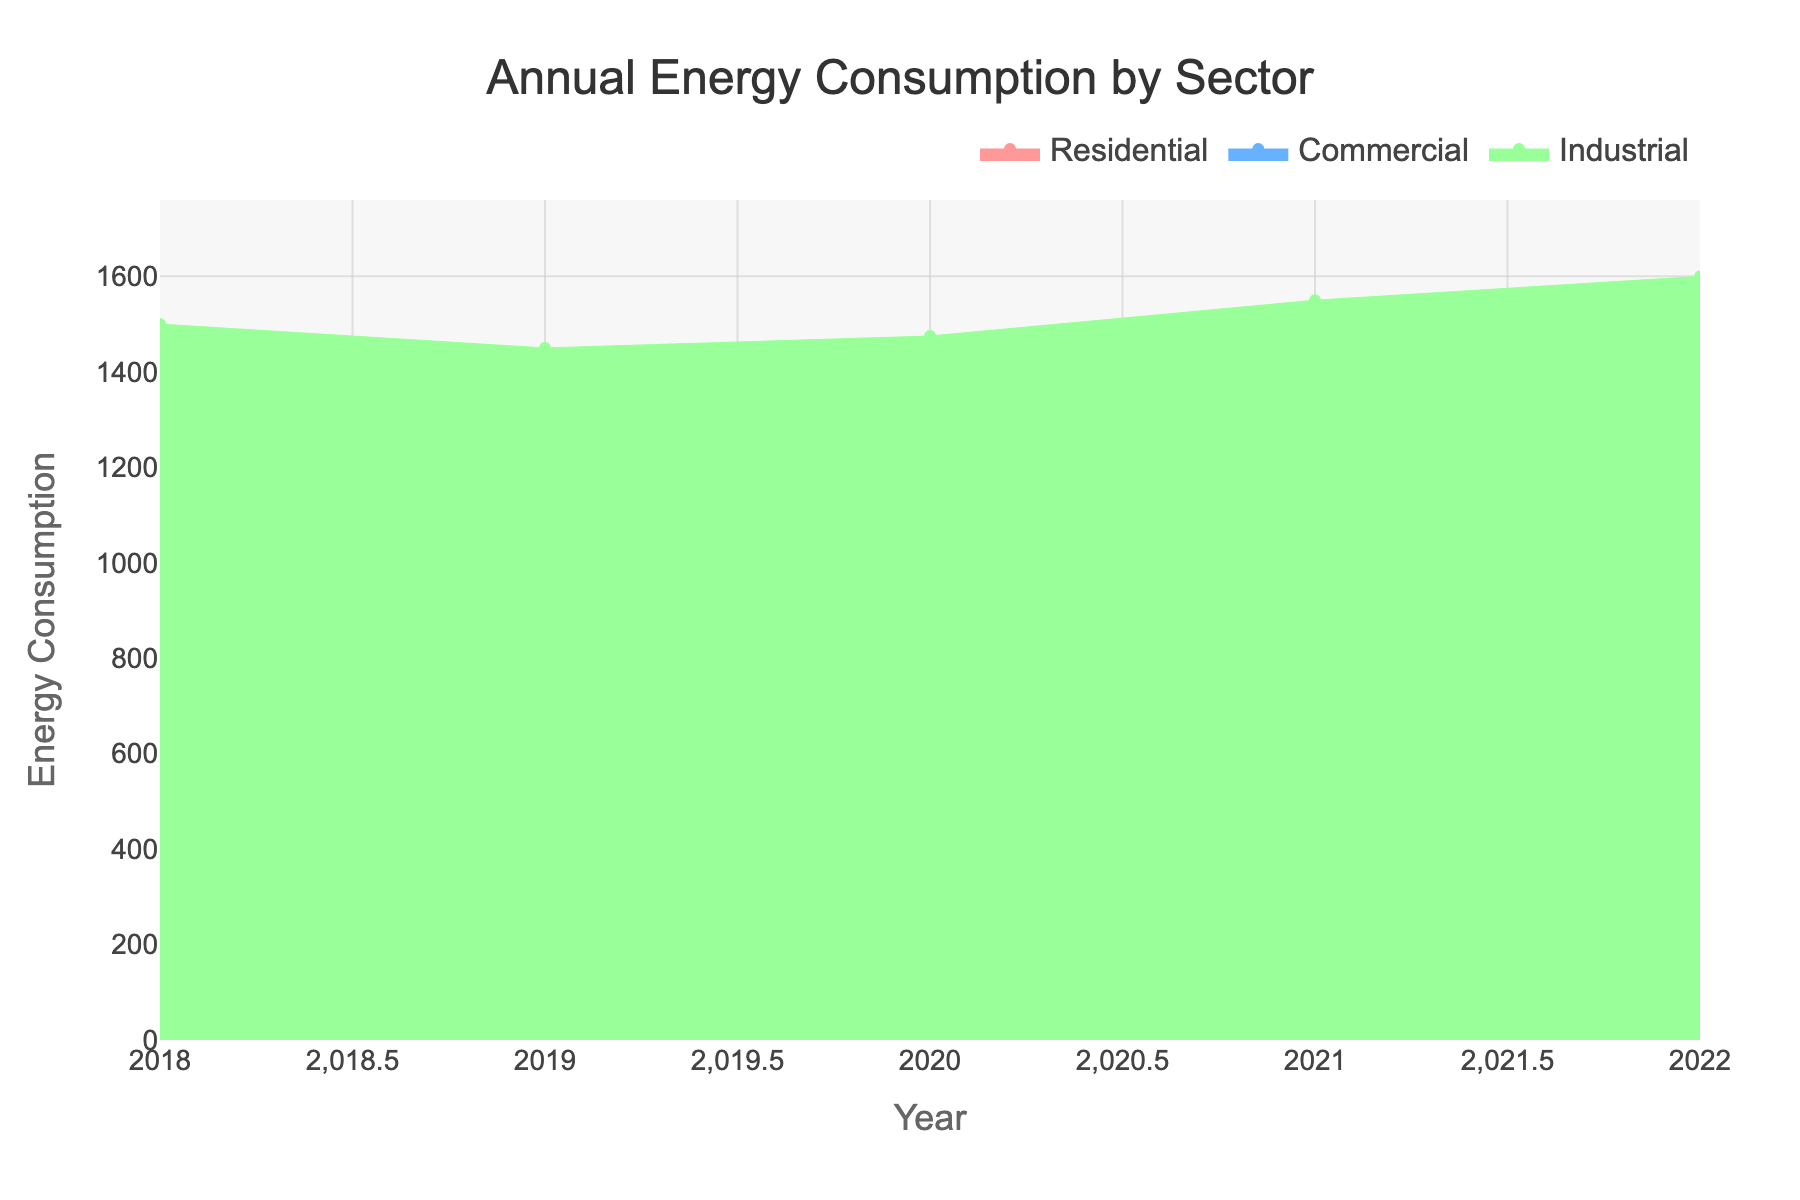What is the title of the figure? The title of the figure is located at the top center. It reads "Annual Energy Consumption by Sector."
Answer: Annual Energy Consumption by Sector What years are included in the figure? The x-axis represents the years, which include 2018, 2019, 2020, 2021, and 2022.
Answer: 2018, 2019, 2020, 2021, 2022 Which sector has the highest energy consumption in 2022? By observing the height of the streams in the year 2022, the Industrial sector has the highest energy consumption.
Answer: Industrial What is the total energy consumption across all sectors in 2018? Sum the values of all sectors for the year 2018: Residential (1200) + Commercial (900) + Industrial (1500). 1200 + 900 + 1500 = 3600.
Answer: 3600 How has the Industrial sector's energy consumption changed from 2018 to 2022? By comparing the stream heights for the Industrial sector between 2018 (1500) and 2022 (1600), we see an increase of 100 units: 1600 - 1500 = 100.
Answer: Increased by 100 Which year saw the highest total energy consumption across all sectors? Calculate the sum for each year and compare: 
2018 = 1200 + 900 + 1500 = 3600 
2019 = 1300 + 950 + 1450 = 3700 
2020 = 1250 + 1000 + 1475 = 3725 
2021 = 1400 + 1050 + 1550 = 4000 
2022 = 1350 + 1100 + 1600 = 4050 
2022 has the highest total.
Answer: 2022 Which sector saw the largest increase in energy consumption from 2018 to 2022? Calculate the differences for each sector: 
Residential: 1350 - 1200 = 150 
Commercial: 1100 - 900 = 200 
Industrial: 1600 - 1500 = 100 
The Commercial sector saw the largest increase.
Answer: Commercial What is the average energy consumption for the Commercial sector over the five years? Sum the Commercial values and divide by 5: (900 + 950 + 1000 + 1050 + 1100) / 5 = 5000 / 5 = 1000.
Answer: 1000 Which two sectors had the closest energy consumption values in 2020? Comparing 2020 values: 
Residential: 1250 
Commercial: 1000 
Industrial: 1475 
The Residential and Industrial sectors had a difference of 225 (1475 - 1250), closest to each other.
Answer: Residential and Industrial 